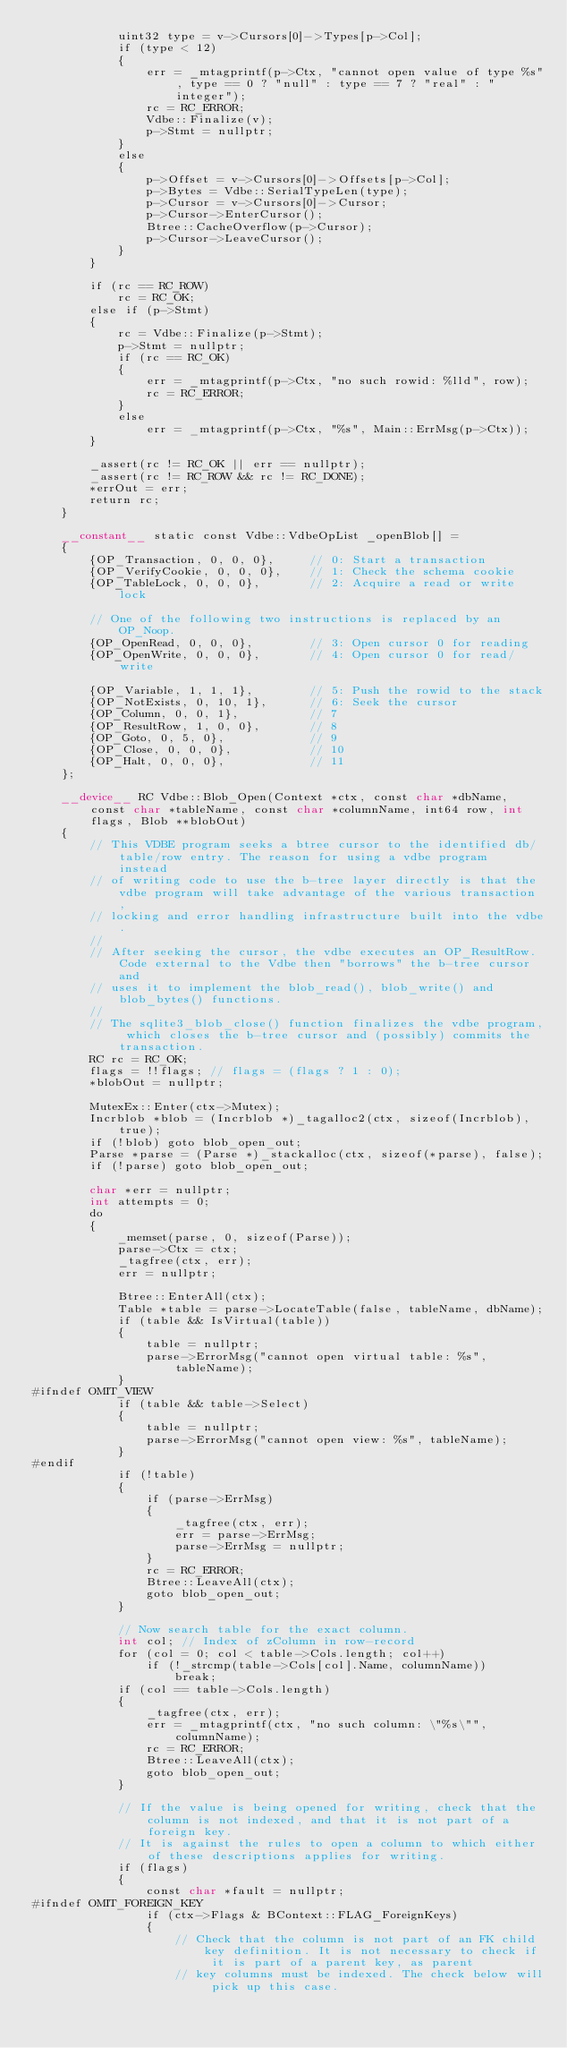Convert code to text. <code><loc_0><loc_0><loc_500><loc_500><_Cuda_>			uint32 type = v->Cursors[0]->Types[p->Col];
			if (type < 12)
			{
				err = _mtagprintf(p->Ctx, "cannot open value of type %s", type == 0 ? "null" : type == 7 ? "real" : "integer");
				rc = RC_ERROR;
				Vdbe::Finalize(v);
				p->Stmt = nullptr;
			}
			else
			{
				p->Offset = v->Cursors[0]->Offsets[p->Col];
				p->Bytes = Vdbe::SerialTypeLen(type);
				p->Cursor = v->Cursors[0]->Cursor;
				p->Cursor->EnterCursor();
				Btree::CacheOverflow(p->Cursor);
				p->Cursor->LeaveCursor();
			}
		}

		if (rc == RC_ROW)
			rc = RC_OK;
		else if (p->Stmt)
		{
			rc = Vdbe::Finalize(p->Stmt);
			p->Stmt = nullptr;
			if (rc == RC_OK)
			{
				err = _mtagprintf(p->Ctx, "no such rowid: %lld", row);
				rc = RC_ERROR;
			}
			else
				err = _mtagprintf(p->Ctx, "%s", Main::ErrMsg(p->Ctx));
		}

		_assert(rc != RC_OK || err == nullptr);
		_assert(rc != RC_ROW && rc != RC_DONE);
		*errOut = err;
		return rc;
	}

	__constant__ static const Vdbe::VdbeOpList _openBlob[] =
	{
		{OP_Transaction, 0, 0, 0},     // 0: Start a transaction
		{OP_VerifyCookie, 0, 0, 0},    // 1: Check the schema cookie
		{OP_TableLock, 0, 0, 0},       // 2: Acquire a read or write lock

		// One of the following two instructions is replaced by an OP_Noop.
		{OP_OpenRead, 0, 0, 0},        // 3: Open cursor 0 for reading
		{OP_OpenWrite, 0, 0, 0},       // 4: Open cursor 0 for read/write

		{OP_Variable, 1, 1, 1},        // 5: Push the rowid to the stack
		{OP_NotExists, 0, 10, 1},      // 6: Seek the cursor
		{OP_Column, 0, 0, 1},          // 7
		{OP_ResultRow, 1, 0, 0},       // 8
		{OP_Goto, 0, 5, 0},            // 9
		{OP_Close, 0, 0, 0},           // 10
		{OP_Halt, 0, 0, 0},            // 11
	};

	__device__ RC Vdbe::Blob_Open(Context *ctx, const char *dbName, const char *tableName, const char *columnName, int64 row, int flags, Blob **blobOut)
	{
		// This VDBE program seeks a btree cursor to the identified db/table/row entry. The reason for using a vdbe program instead
		// of writing code to use the b-tree layer directly is that the vdbe program will take advantage of the various transaction,
		// locking and error handling infrastructure built into the vdbe.
		//
		// After seeking the cursor, the vdbe executes an OP_ResultRow. Code external to the Vdbe then "borrows" the b-tree cursor and
		// uses it to implement the blob_read(), blob_write() and blob_bytes() functions.
		//
		// The sqlite3_blob_close() function finalizes the vdbe program, which closes the b-tree cursor and (possibly) commits the transaction.
		RC rc = RC_OK;
		flags = !!flags; // flags = (flags ? 1 : 0);
		*blobOut = nullptr;

		MutexEx::Enter(ctx->Mutex);
		Incrblob *blob = (Incrblob *)_tagalloc2(ctx, sizeof(Incrblob), true);
		if (!blob) goto blob_open_out;
		Parse *parse = (Parse *)_stackalloc(ctx, sizeof(*parse), false);
		if (!parse) goto blob_open_out;

		char *err = nullptr;
		int attempts = 0;
		do
		{
			_memset(parse, 0, sizeof(Parse));
			parse->Ctx = ctx;
			_tagfree(ctx, err);
			err = nullptr;

			Btree::EnterAll(ctx);
			Table *table = parse->LocateTable(false, tableName, dbName);
			if (table && IsVirtual(table))
			{
				table = nullptr;
				parse->ErrorMsg("cannot open virtual table: %s", tableName);
			}
#ifndef OMIT_VIEW
			if (table && table->Select)
			{
				table = nullptr;
				parse->ErrorMsg("cannot open view: %s", tableName);
			}
#endif
			if (!table)
			{
				if (parse->ErrMsg)
				{
					_tagfree(ctx, err);
					err = parse->ErrMsg;
					parse->ErrMsg = nullptr;
				}
				rc = RC_ERROR;
				Btree::LeaveAll(ctx);
				goto blob_open_out;
			}

			// Now search table for the exact column.
			int col; // Index of zColumn in row-record
			for (col = 0; col < table->Cols.length; col++)
				if (!_strcmp(table->Cols[col].Name, columnName))
					break;
			if (col == table->Cols.length)
			{
				_tagfree(ctx, err);
				err = _mtagprintf(ctx, "no such column: \"%s\"", columnName);
				rc = RC_ERROR;
				Btree::LeaveAll(ctx);
				goto blob_open_out;
			}

			// If the value is being opened for writing, check that the column is not indexed, and that it is not part of a foreign key. 
			// It is against the rules to open a column to which either of these descriptions applies for writing.
			if (flags)
			{
				const char *fault = nullptr;
#ifndef OMIT_FOREIGN_KEY
				if (ctx->Flags & BContext::FLAG_ForeignKeys)
				{
					// Check that the column is not part of an FK child key definition. It is not necessary to check if it is part of a parent key, as parent
					// key columns must be indexed. The check below will pick up this case.</code> 